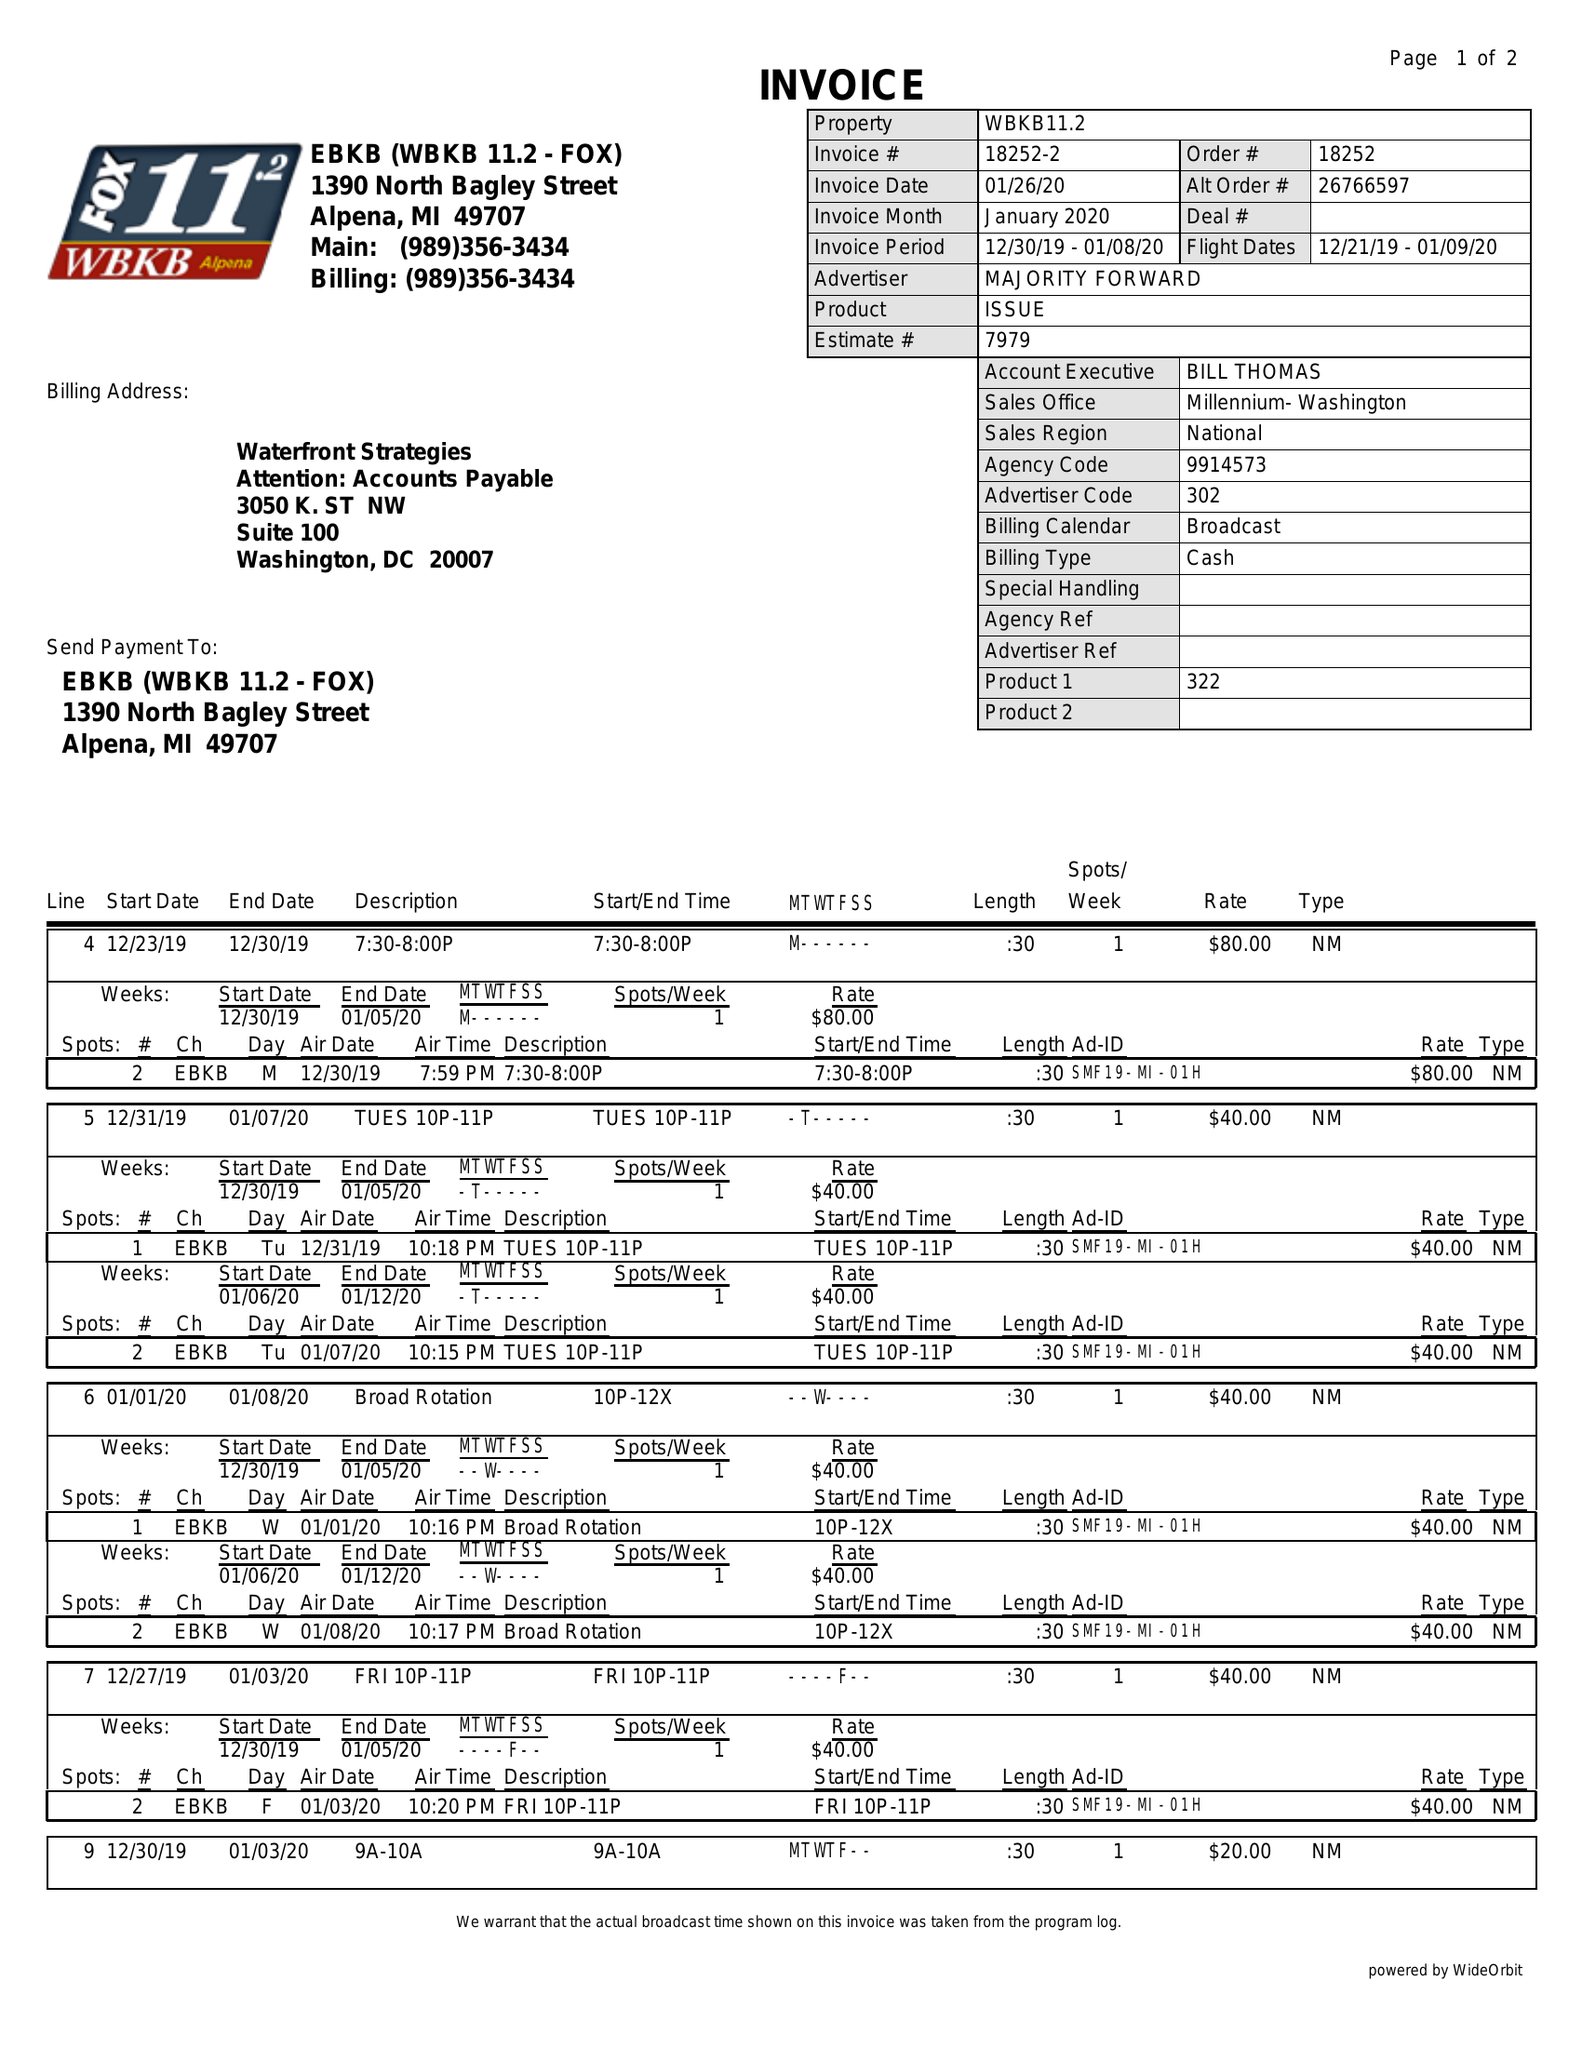What is the value for the gross_amount?
Answer the question using a single word or phrase. 650.00 